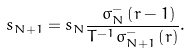Convert formula to latex. <formula><loc_0><loc_0><loc_500><loc_500>s _ { N + 1 } = s _ { N } \frac { \ \sigma _ { N } ^ { - } \left ( r - 1 \right ) } { T ^ { - 1 } \sigma _ { N + 1 } ^ { - } \left ( r \right ) } .</formula> 